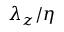<formula> <loc_0><loc_0><loc_500><loc_500>\lambda _ { z } / \eta</formula> 